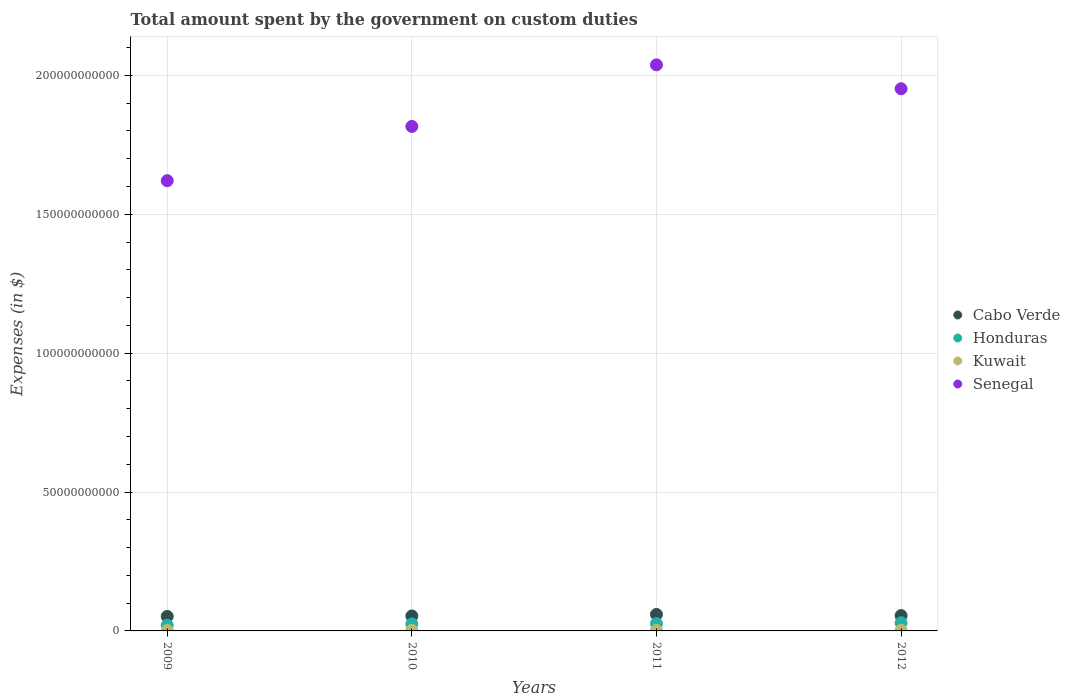Is the number of dotlines equal to the number of legend labels?
Offer a very short reply. Yes. What is the amount spent on custom duties by the government in Kuwait in 2010?
Give a very brief answer. 2.18e+08. Across all years, what is the maximum amount spent on custom duties by the government in Senegal?
Offer a very short reply. 2.04e+11. Across all years, what is the minimum amount spent on custom duties by the government in Cabo Verde?
Your answer should be very brief. 5.22e+09. In which year was the amount spent on custom duties by the government in Honduras maximum?
Make the answer very short. 2012. What is the total amount spent on custom duties by the government in Cabo Verde in the graph?
Ensure brevity in your answer.  2.21e+1. What is the difference between the amount spent on custom duties by the government in Honduras in 2011 and that in 2012?
Give a very brief answer. -3.06e+08. What is the difference between the amount spent on custom duties by the government in Cabo Verde in 2011 and the amount spent on custom duties by the government in Kuwait in 2010?
Keep it short and to the point. 5.72e+09. What is the average amount spent on custom duties by the government in Kuwait per year?
Offer a very short reply. 2.23e+08. In the year 2010, what is the difference between the amount spent on custom duties by the government in Senegal and amount spent on custom duties by the government in Kuwait?
Ensure brevity in your answer.  1.81e+11. What is the ratio of the amount spent on custom duties by the government in Honduras in 2009 to that in 2012?
Your answer should be very brief. 0.7. Is the amount spent on custom duties by the government in Kuwait in 2009 less than that in 2012?
Give a very brief answer. Yes. Is the difference between the amount spent on custom duties by the government in Senegal in 2009 and 2011 greater than the difference between the amount spent on custom duties by the government in Kuwait in 2009 and 2011?
Provide a short and direct response. No. What is the difference between the highest and the second highest amount spent on custom duties by the government in Senegal?
Make the answer very short. 8.60e+09. What is the difference between the highest and the lowest amount spent on custom duties by the government in Cabo Verde?
Offer a very short reply. 7.19e+08. Is it the case that in every year, the sum of the amount spent on custom duties by the government in Cabo Verde and amount spent on custom duties by the government in Honduras  is greater than the sum of amount spent on custom duties by the government in Senegal and amount spent on custom duties by the government in Kuwait?
Your answer should be very brief. Yes. Does the amount spent on custom duties by the government in Senegal monotonically increase over the years?
Your answer should be compact. No. Is the amount spent on custom duties by the government in Kuwait strictly greater than the amount spent on custom duties by the government in Honduras over the years?
Provide a short and direct response. No. How many dotlines are there?
Make the answer very short. 4. How many years are there in the graph?
Your answer should be compact. 4. Does the graph contain any zero values?
Offer a very short reply. No. Does the graph contain grids?
Give a very brief answer. Yes. Where does the legend appear in the graph?
Offer a very short reply. Center right. How many legend labels are there?
Make the answer very short. 4. How are the legend labels stacked?
Ensure brevity in your answer.  Vertical. What is the title of the graph?
Offer a very short reply. Total amount spent by the government on custom duties. What is the label or title of the Y-axis?
Give a very brief answer. Expenses (in $). What is the Expenses (in $) of Cabo Verde in 2009?
Provide a succinct answer. 5.22e+09. What is the Expenses (in $) of Honduras in 2009?
Your response must be concise. 2.07e+09. What is the Expenses (in $) of Kuwait in 2009?
Give a very brief answer. 1.91e+08. What is the Expenses (in $) of Senegal in 2009?
Your answer should be compact. 1.62e+11. What is the Expenses (in $) in Cabo Verde in 2010?
Provide a succinct answer. 5.39e+09. What is the Expenses (in $) in Honduras in 2010?
Make the answer very short. 2.51e+09. What is the Expenses (in $) in Kuwait in 2010?
Your response must be concise. 2.18e+08. What is the Expenses (in $) in Senegal in 2010?
Give a very brief answer. 1.82e+11. What is the Expenses (in $) in Cabo Verde in 2011?
Provide a short and direct response. 5.94e+09. What is the Expenses (in $) of Honduras in 2011?
Give a very brief answer. 2.63e+09. What is the Expenses (in $) in Kuwait in 2011?
Make the answer very short. 2.23e+08. What is the Expenses (in $) of Senegal in 2011?
Your response must be concise. 2.04e+11. What is the Expenses (in $) in Cabo Verde in 2012?
Give a very brief answer. 5.52e+09. What is the Expenses (in $) of Honduras in 2012?
Your answer should be very brief. 2.93e+09. What is the Expenses (in $) in Kuwait in 2012?
Ensure brevity in your answer.  2.59e+08. What is the Expenses (in $) of Senegal in 2012?
Make the answer very short. 1.95e+11. Across all years, what is the maximum Expenses (in $) in Cabo Verde?
Provide a succinct answer. 5.94e+09. Across all years, what is the maximum Expenses (in $) in Honduras?
Make the answer very short. 2.93e+09. Across all years, what is the maximum Expenses (in $) of Kuwait?
Your answer should be very brief. 2.59e+08. Across all years, what is the maximum Expenses (in $) in Senegal?
Offer a terse response. 2.04e+11. Across all years, what is the minimum Expenses (in $) in Cabo Verde?
Offer a very short reply. 5.22e+09. Across all years, what is the minimum Expenses (in $) of Honduras?
Your answer should be compact. 2.07e+09. Across all years, what is the minimum Expenses (in $) in Kuwait?
Your answer should be compact. 1.91e+08. Across all years, what is the minimum Expenses (in $) in Senegal?
Offer a terse response. 1.62e+11. What is the total Expenses (in $) in Cabo Verde in the graph?
Provide a succinct answer. 2.21e+1. What is the total Expenses (in $) of Honduras in the graph?
Offer a terse response. 1.01e+1. What is the total Expenses (in $) of Kuwait in the graph?
Offer a very short reply. 8.91e+08. What is the total Expenses (in $) of Senegal in the graph?
Your answer should be very brief. 7.43e+11. What is the difference between the Expenses (in $) of Cabo Verde in 2009 and that in 2010?
Offer a very short reply. -1.69e+08. What is the difference between the Expenses (in $) of Honduras in 2009 and that in 2010?
Provide a succinct answer. -4.40e+08. What is the difference between the Expenses (in $) in Kuwait in 2009 and that in 2010?
Keep it short and to the point. -2.70e+07. What is the difference between the Expenses (in $) in Senegal in 2009 and that in 2010?
Give a very brief answer. -1.95e+1. What is the difference between the Expenses (in $) of Cabo Verde in 2009 and that in 2011?
Your answer should be very brief. -7.19e+08. What is the difference between the Expenses (in $) of Honduras in 2009 and that in 2011?
Keep it short and to the point. -5.61e+08. What is the difference between the Expenses (in $) in Kuwait in 2009 and that in 2011?
Offer a terse response. -3.20e+07. What is the difference between the Expenses (in $) of Senegal in 2009 and that in 2011?
Offer a very short reply. -4.17e+1. What is the difference between the Expenses (in $) of Cabo Verde in 2009 and that in 2012?
Your answer should be compact. -2.97e+08. What is the difference between the Expenses (in $) in Honduras in 2009 and that in 2012?
Offer a terse response. -8.67e+08. What is the difference between the Expenses (in $) of Kuwait in 2009 and that in 2012?
Keep it short and to the point. -6.80e+07. What is the difference between the Expenses (in $) in Senegal in 2009 and that in 2012?
Your response must be concise. -3.31e+1. What is the difference between the Expenses (in $) of Cabo Verde in 2010 and that in 2011?
Your answer should be very brief. -5.49e+08. What is the difference between the Expenses (in $) of Honduras in 2010 and that in 2011?
Keep it short and to the point. -1.21e+08. What is the difference between the Expenses (in $) of Kuwait in 2010 and that in 2011?
Your answer should be compact. -5.00e+06. What is the difference between the Expenses (in $) of Senegal in 2010 and that in 2011?
Give a very brief answer. -2.22e+1. What is the difference between the Expenses (in $) in Cabo Verde in 2010 and that in 2012?
Keep it short and to the point. -1.27e+08. What is the difference between the Expenses (in $) in Honduras in 2010 and that in 2012?
Provide a short and direct response. -4.27e+08. What is the difference between the Expenses (in $) of Kuwait in 2010 and that in 2012?
Your answer should be very brief. -4.10e+07. What is the difference between the Expenses (in $) in Senegal in 2010 and that in 2012?
Provide a short and direct response. -1.36e+1. What is the difference between the Expenses (in $) in Cabo Verde in 2011 and that in 2012?
Offer a very short reply. 4.22e+08. What is the difference between the Expenses (in $) in Honduras in 2011 and that in 2012?
Offer a terse response. -3.06e+08. What is the difference between the Expenses (in $) of Kuwait in 2011 and that in 2012?
Give a very brief answer. -3.60e+07. What is the difference between the Expenses (in $) in Senegal in 2011 and that in 2012?
Your response must be concise. 8.60e+09. What is the difference between the Expenses (in $) in Cabo Verde in 2009 and the Expenses (in $) in Honduras in 2010?
Your response must be concise. 2.71e+09. What is the difference between the Expenses (in $) of Cabo Verde in 2009 and the Expenses (in $) of Kuwait in 2010?
Provide a succinct answer. 5.00e+09. What is the difference between the Expenses (in $) in Cabo Verde in 2009 and the Expenses (in $) in Senegal in 2010?
Provide a short and direct response. -1.76e+11. What is the difference between the Expenses (in $) of Honduras in 2009 and the Expenses (in $) of Kuwait in 2010?
Offer a terse response. 1.85e+09. What is the difference between the Expenses (in $) of Honduras in 2009 and the Expenses (in $) of Senegal in 2010?
Your answer should be compact. -1.80e+11. What is the difference between the Expenses (in $) of Kuwait in 2009 and the Expenses (in $) of Senegal in 2010?
Your response must be concise. -1.81e+11. What is the difference between the Expenses (in $) of Cabo Verde in 2009 and the Expenses (in $) of Honduras in 2011?
Make the answer very short. 2.59e+09. What is the difference between the Expenses (in $) of Cabo Verde in 2009 and the Expenses (in $) of Kuwait in 2011?
Keep it short and to the point. 5.00e+09. What is the difference between the Expenses (in $) in Cabo Verde in 2009 and the Expenses (in $) in Senegal in 2011?
Give a very brief answer. -1.99e+11. What is the difference between the Expenses (in $) in Honduras in 2009 and the Expenses (in $) in Kuwait in 2011?
Provide a short and direct response. 1.84e+09. What is the difference between the Expenses (in $) in Honduras in 2009 and the Expenses (in $) in Senegal in 2011?
Make the answer very short. -2.02e+11. What is the difference between the Expenses (in $) in Kuwait in 2009 and the Expenses (in $) in Senegal in 2011?
Keep it short and to the point. -2.04e+11. What is the difference between the Expenses (in $) of Cabo Verde in 2009 and the Expenses (in $) of Honduras in 2012?
Give a very brief answer. 2.29e+09. What is the difference between the Expenses (in $) of Cabo Verde in 2009 and the Expenses (in $) of Kuwait in 2012?
Offer a terse response. 4.96e+09. What is the difference between the Expenses (in $) in Cabo Verde in 2009 and the Expenses (in $) in Senegal in 2012?
Your response must be concise. -1.90e+11. What is the difference between the Expenses (in $) in Honduras in 2009 and the Expenses (in $) in Kuwait in 2012?
Provide a short and direct response. 1.81e+09. What is the difference between the Expenses (in $) of Honduras in 2009 and the Expenses (in $) of Senegal in 2012?
Provide a short and direct response. -1.93e+11. What is the difference between the Expenses (in $) of Kuwait in 2009 and the Expenses (in $) of Senegal in 2012?
Make the answer very short. -1.95e+11. What is the difference between the Expenses (in $) of Cabo Verde in 2010 and the Expenses (in $) of Honduras in 2011?
Your answer should be very brief. 2.76e+09. What is the difference between the Expenses (in $) of Cabo Verde in 2010 and the Expenses (in $) of Kuwait in 2011?
Keep it short and to the point. 5.17e+09. What is the difference between the Expenses (in $) of Cabo Verde in 2010 and the Expenses (in $) of Senegal in 2011?
Your answer should be very brief. -1.98e+11. What is the difference between the Expenses (in $) of Honduras in 2010 and the Expenses (in $) of Kuwait in 2011?
Make the answer very short. 2.28e+09. What is the difference between the Expenses (in $) in Honduras in 2010 and the Expenses (in $) in Senegal in 2011?
Offer a terse response. -2.01e+11. What is the difference between the Expenses (in $) in Kuwait in 2010 and the Expenses (in $) in Senegal in 2011?
Give a very brief answer. -2.04e+11. What is the difference between the Expenses (in $) in Cabo Verde in 2010 and the Expenses (in $) in Honduras in 2012?
Provide a succinct answer. 2.46e+09. What is the difference between the Expenses (in $) in Cabo Verde in 2010 and the Expenses (in $) in Kuwait in 2012?
Offer a terse response. 5.13e+09. What is the difference between the Expenses (in $) of Cabo Verde in 2010 and the Expenses (in $) of Senegal in 2012?
Offer a very short reply. -1.90e+11. What is the difference between the Expenses (in $) of Honduras in 2010 and the Expenses (in $) of Kuwait in 2012?
Make the answer very short. 2.25e+09. What is the difference between the Expenses (in $) in Honduras in 2010 and the Expenses (in $) in Senegal in 2012?
Offer a terse response. -1.93e+11. What is the difference between the Expenses (in $) in Kuwait in 2010 and the Expenses (in $) in Senegal in 2012?
Your answer should be compact. -1.95e+11. What is the difference between the Expenses (in $) of Cabo Verde in 2011 and the Expenses (in $) of Honduras in 2012?
Ensure brevity in your answer.  3.01e+09. What is the difference between the Expenses (in $) in Cabo Verde in 2011 and the Expenses (in $) in Kuwait in 2012?
Keep it short and to the point. 5.68e+09. What is the difference between the Expenses (in $) of Cabo Verde in 2011 and the Expenses (in $) of Senegal in 2012?
Provide a short and direct response. -1.89e+11. What is the difference between the Expenses (in $) of Honduras in 2011 and the Expenses (in $) of Kuwait in 2012?
Provide a short and direct response. 2.37e+09. What is the difference between the Expenses (in $) in Honduras in 2011 and the Expenses (in $) in Senegal in 2012?
Give a very brief answer. -1.93e+11. What is the difference between the Expenses (in $) of Kuwait in 2011 and the Expenses (in $) of Senegal in 2012?
Make the answer very short. -1.95e+11. What is the average Expenses (in $) in Cabo Verde per year?
Your response must be concise. 5.52e+09. What is the average Expenses (in $) in Honduras per year?
Offer a terse response. 2.53e+09. What is the average Expenses (in $) of Kuwait per year?
Ensure brevity in your answer.  2.23e+08. What is the average Expenses (in $) in Senegal per year?
Make the answer very short. 1.86e+11. In the year 2009, what is the difference between the Expenses (in $) of Cabo Verde and Expenses (in $) of Honduras?
Keep it short and to the point. 3.15e+09. In the year 2009, what is the difference between the Expenses (in $) of Cabo Verde and Expenses (in $) of Kuwait?
Your answer should be compact. 5.03e+09. In the year 2009, what is the difference between the Expenses (in $) of Cabo Verde and Expenses (in $) of Senegal?
Provide a short and direct response. -1.57e+11. In the year 2009, what is the difference between the Expenses (in $) in Honduras and Expenses (in $) in Kuwait?
Provide a short and direct response. 1.87e+09. In the year 2009, what is the difference between the Expenses (in $) in Honduras and Expenses (in $) in Senegal?
Your answer should be compact. -1.60e+11. In the year 2009, what is the difference between the Expenses (in $) in Kuwait and Expenses (in $) in Senegal?
Give a very brief answer. -1.62e+11. In the year 2010, what is the difference between the Expenses (in $) in Cabo Verde and Expenses (in $) in Honduras?
Your answer should be very brief. 2.88e+09. In the year 2010, what is the difference between the Expenses (in $) in Cabo Verde and Expenses (in $) in Kuwait?
Keep it short and to the point. 5.17e+09. In the year 2010, what is the difference between the Expenses (in $) in Cabo Verde and Expenses (in $) in Senegal?
Offer a very short reply. -1.76e+11. In the year 2010, what is the difference between the Expenses (in $) of Honduras and Expenses (in $) of Kuwait?
Ensure brevity in your answer.  2.29e+09. In the year 2010, what is the difference between the Expenses (in $) in Honduras and Expenses (in $) in Senegal?
Keep it short and to the point. -1.79e+11. In the year 2010, what is the difference between the Expenses (in $) of Kuwait and Expenses (in $) of Senegal?
Offer a very short reply. -1.81e+11. In the year 2011, what is the difference between the Expenses (in $) of Cabo Verde and Expenses (in $) of Honduras?
Provide a short and direct response. 3.31e+09. In the year 2011, what is the difference between the Expenses (in $) of Cabo Verde and Expenses (in $) of Kuwait?
Make the answer very short. 5.71e+09. In the year 2011, what is the difference between the Expenses (in $) in Cabo Verde and Expenses (in $) in Senegal?
Your response must be concise. -1.98e+11. In the year 2011, what is the difference between the Expenses (in $) of Honduras and Expenses (in $) of Kuwait?
Give a very brief answer. 2.40e+09. In the year 2011, what is the difference between the Expenses (in $) of Honduras and Expenses (in $) of Senegal?
Provide a short and direct response. -2.01e+11. In the year 2011, what is the difference between the Expenses (in $) in Kuwait and Expenses (in $) in Senegal?
Ensure brevity in your answer.  -2.04e+11. In the year 2012, what is the difference between the Expenses (in $) of Cabo Verde and Expenses (in $) of Honduras?
Make the answer very short. 2.58e+09. In the year 2012, what is the difference between the Expenses (in $) in Cabo Verde and Expenses (in $) in Kuwait?
Keep it short and to the point. 5.26e+09. In the year 2012, what is the difference between the Expenses (in $) of Cabo Verde and Expenses (in $) of Senegal?
Your answer should be very brief. -1.90e+11. In the year 2012, what is the difference between the Expenses (in $) in Honduras and Expenses (in $) in Kuwait?
Make the answer very short. 2.67e+09. In the year 2012, what is the difference between the Expenses (in $) of Honduras and Expenses (in $) of Senegal?
Offer a terse response. -1.92e+11. In the year 2012, what is the difference between the Expenses (in $) in Kuwait and Expenses (in $) in Senegal?
Provide a short and direct response. -1.95e+11. What is the ratio of the Expenses (in $) of Cabo Verde in 2009 to that in 2010?
Your response must be concise. 0.97. What is the ratio of the Expenses (in $) in Honduras in 2009 to that in 2010?
Your answer should be compact. 0.82. What is the ratio of the Expenses (in $) of Kuwait in 2009 to that in 2010?
Your answer should be compact. 0.88. What is the ratio of the Expenses (in $) of Senegal in 2009 to that in 2010?
Provide a succinct answer. 0.89. What is the ratio of the Expenses (in $) of Cabo Verde in 2009 to that in 2011?
Your response must be concise. 0.88. What is the ratio of the Expenses (in $) of Honduras in 2009 to that in 2011?
Make the answer very short. 0.79. What is the ratio of the Expenses (in $) of Kuwait in 2009 to that in 2011?
Keep it short and to the point. 0.86. What is the ratio of the Expenses (in $) of Senegal in 2009 to that in 2011?
Your response must be concise. 0.8. What is the ratio of the Expenses (in $) in Cabo Verde in 2009 to that in 2012?
Your response must be concise. 0.95. What is the ratio of the Expenses (in $) in Honduras in 2009 to that in 2012?
Keep it short and to the point. 0.7. What is the ratio of the Expenses (in $) in Kuwait in 2009 to that in 2012?
Offer a very short reply. 0.74. What is the ratio of the Expenses (in $) of Senegal in 2009 to that in 2012?
Offer a very short reply. 0.83. What is the ratio of the Expenses (in $) of Cabo Verde in 2010 to that in 2011?
Offer a very short reply. 0.91. What is the ratio of the Expenses (in $) in Honduras in 2010 to that in 2011?
Offer a very short reply. 0.95. What is the ratio of the Expenses (in $) in Kuwait in 2010 to that in 2011?
Your answer should be compact. 0.98. What is the ratio of the Expenses (in $) of Senegal in 2010 to that in 2011?
Provide a short and direct response. 0.89. What is the ratio of the Expenses (in $) of Cabo Verde in 2010 to that in 2012?
Offer a very short reply. 0.98. What is the ratio of the Expenses (in $) of Honduras in 2010 to that in 2012?
Your answer should be compact. 0.85. What is the ratio of the Expenses (in $) of Kuwait in 2010 to that in 2012?
Provide a succinct answer. 0.84. What is the ratio of the Expenses (in $) in Senegal in 2010 to that in 2012?
Your response must be concise. 0.93. What is the ratio of the Expenses (in $) in Cabo Verde in 2011 to that in 2012?
Make the answer very short. 1.08. What is the ratio of the Expenses (in $) of Honduras in 2011 to that in 2012?
Your answer should be very brief. 0.9. What is the ratio of the Expenses (in $) in Kuwait in 2011 to that in 2012?
Keep it short and to the point. 0.86. What is the ratio of the Expenses (in $) in Senegal in 2011 to that in 2012?
Make the answer very short. 1.04. What is the difference between the highest and the second highest Expenses (in $) of Cabo Verde?
Provide a short and direct response. 4.22e+08. What is the difference between the highest and the second highest Expenses (in $) of Honduras?
Offer a terse response. 3.06e+08. What is the difference between the highest and the second highest Expenses (in $) of Kuwait?
Ensure brevity in your answer.  3.60e+07. What is the difference between the highest and the second highest Expenses (in $) of Senegal?
Offer a very short reply. 8.60e+09. What is the difference between the highest and the lowest Expenses (in $) in Cabo Verde?
Keep it short and to the point. 7.19e+08. What is the difference between the highest and the lowest Expenses (in $) in Honduras?
Offer a terse response. 8.67e+08. What is the difference between the highest and the lowest Expenses (in $) of Kuwait?
Keep it short and to the point. 6.80e+07. What is the difference between the highest and the lowest Expenses (in $) in Senegal?
Offer a very short reply. 4.17e+1. 